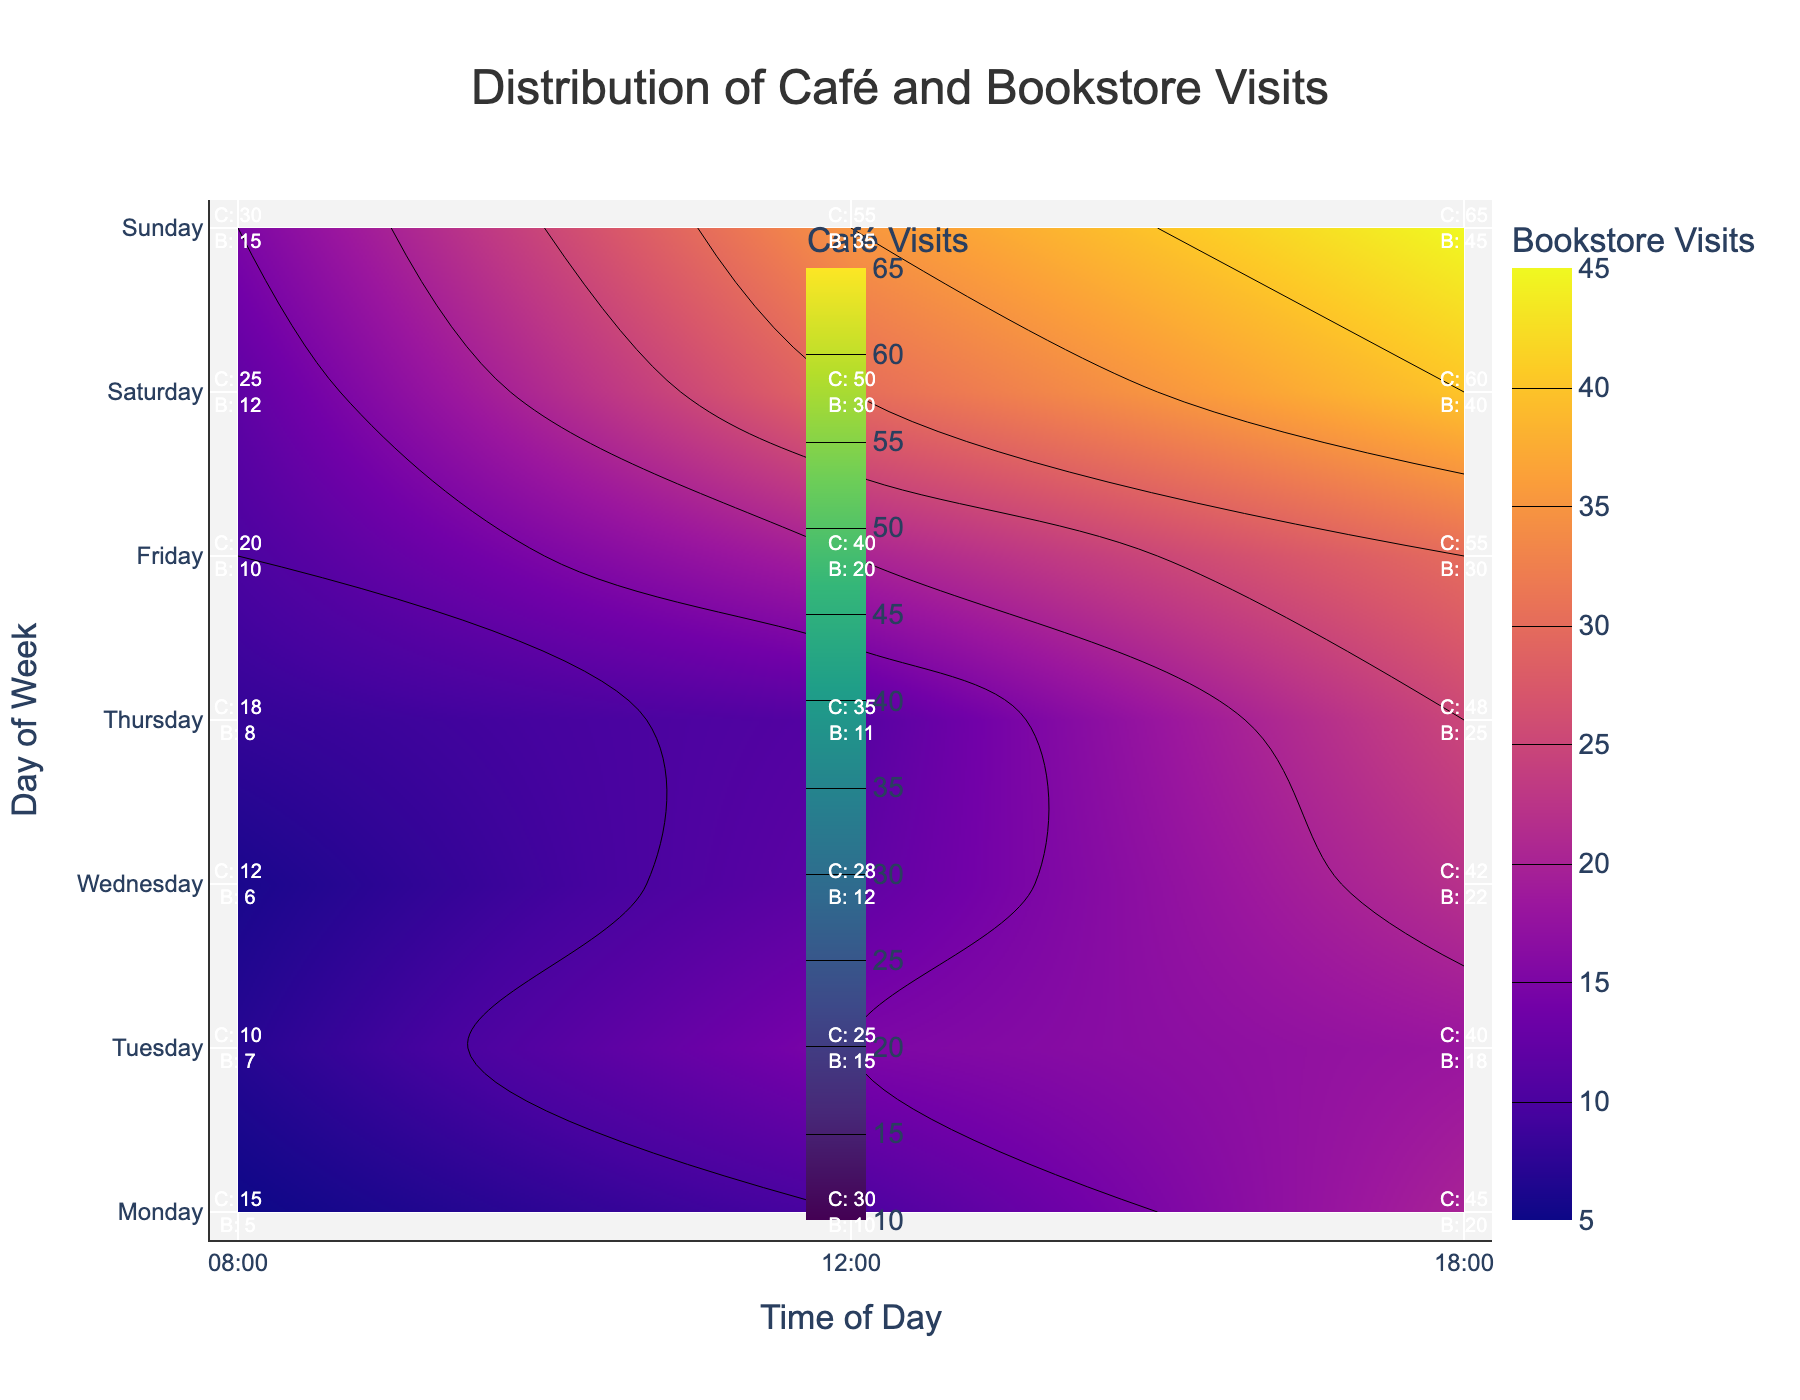What is the title of the plot? The title is at the top of the figure and typically indicates what the plot represents.
Answer: Distribution of Café and Bookstore Visits Which day has the most café visits in the evening? By looking at the café visits data (green scale) for the 18:00 slot across days, the highest value is on Sunday.
Answer: Sunday How many bookstore visits are there on Friday at lunchtime? Find Friday on the y-axis, trace horizontally to 12:00 on the x-axis, and refer to the label. The label indicates 20 bookstore visits.
Answer: 20 Is there any time slot where café visits exceed 60? If so, when? The contour plot with café visits (green scale) shows value ranges. A labeled value exceeding 60 is visible on Sunday at 18:00.
Answer: Yes, Sunday 18:00 Compare bookstore visits on Monday and Wednesday at 12:00. Which is higher? Look at the 12:00 slot for both Monday and Wednesday and compare the labeled bookstore visits. Monday has 10, and Wednesday has 12, so Wednesday is higher.
Answer: Wednesday On which day are bookstore visits consistently increasing from morning to evening? Analyze the labels for bookstore visits for each day and check for increasing values from 08:00 to 18:00. Sunday has 15, 35, and 45, showing consistent increase.
Answer: Sunday What is the average number of café visits on Tuesday? Sum the café visits on Tuesday (08:00: 10, 12:00: 25, 18:00: 40), which equals 75, and divide by 3 (the number of slots).
Answer: 25 Is there any day where bookstore visits are equal between any two time slots? Compare the labeled bookstore visits for each day to identify matches. Tuesday has 7 visits at 08:00 and 18:00.
Answer: Yes, Tuesday How many total café visits are there on Saturday? Sum the café visits for Saturday (08:00: 25, 12:00: 50, 18:00: 60), which equals 135.
Answer: 135 Which time slot generally has the highest café visits during the week? By looking at the café visits across all days, the 18:00 time slot consistently shows higher values compared to 08:00 and 12:00.
Answer: 18:00 